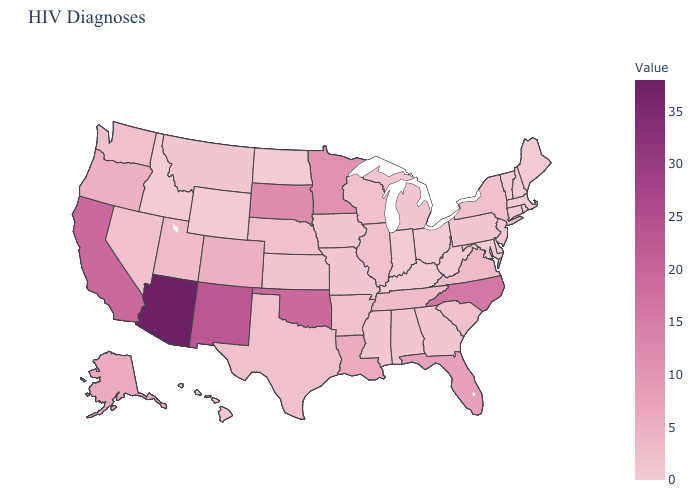Which states have the highest value in the USA?
Short answer required. Arizona. Does West Virginia have the lowest value in the USA?
Write a very short answer. Yes. Does the map have missing data?
Answer briefly. No. Among the states that border Vermont , does New York have the highest value?
Quick response, please. Yes. Does Montana have the lowest value in the USA?
Give a very brief answer. No. 